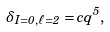<formula> <loc_0><loc_0><loc_500><loc_500>\delta _ { I = 0 , \ell = 2 } = c q ^ { 5 } ,</formula> 